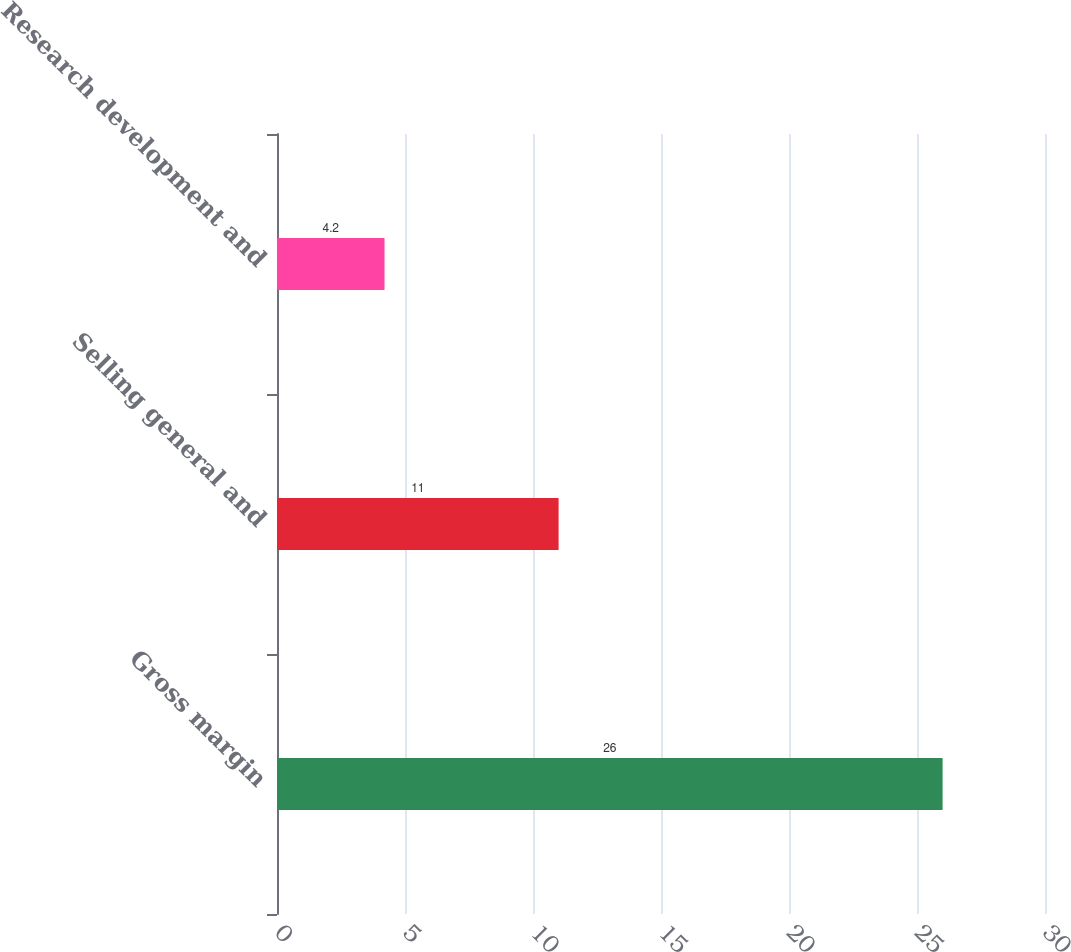<chart> <loc_0><loc_0><loc_500><loc_500><bar_chart><fcel>Gross margin<fcel>Selling general and<fcel>Research development and<nl><fcel>26<fcel>11<fcel>4.2<nl></chart> 